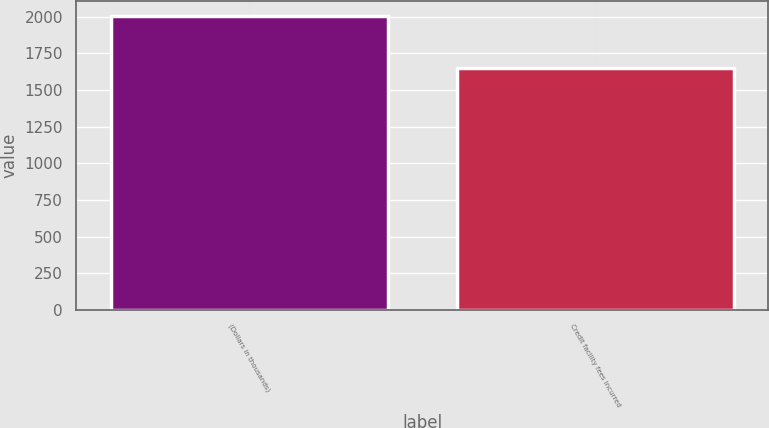Convert chart to OTSL. <chart><loc_0><loc_0><loc_500><loc_500><bar_chart><fcel>(Dollars in thousands)<fcel>Credit facility fees incurred<nl><fcel>2008<fcel>1648<nl></chart> 